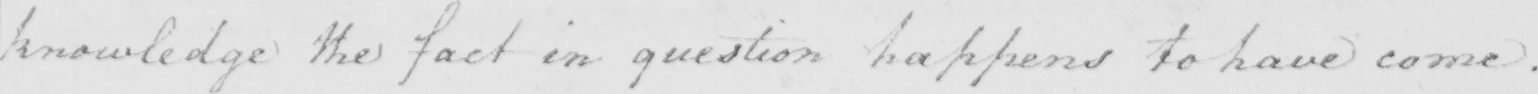Can you read and transcribe this handwriting? knowledge the fact in question happens to have come . 